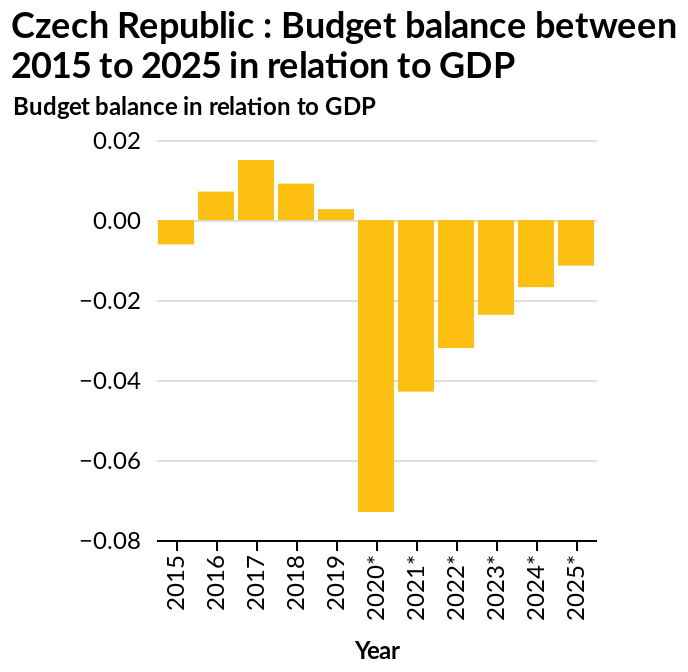<image>
What country does the bar graph represent? The bar graph represents the Czech Republic. What is the value of the bar when it plummets back down in 2020? The value of the bar plummets back down to -0.07 in 2020. What does the x-axis show on the bar graph? The x-axis shows the Year. How would you describe the overall trend of the bar based on the figure? The overall trend of the bar starts in the negatives, peaks above zero, and then plummets back down in 2020. How does the bar change after reaching its peak? The bar peaks above the zero line. What does the y-axis plot on the bar graph? The y-axis plots the Budget balance in relation to GDP. please summary the statistics and relations of the chart Seems like the budget balance in relation to GDP tends to fall since 2020 by roughly half each year. What type of graph is used to represent the budget balance in relation to GDP for the Czech Republic? A bar graph is used to represent the budget balance in relation to GDP for the Czech Republic. please enumerates aspects of the construction of the chart Czech Republic : Budget balance between 2015 to 2025 in relation to GDP is a bar graph. The y-axis plots Budget balance in relation to GDP while the x-axis shows Year. When does the chart experience a significant drop in 2020? The chart experiences a significant drop in 2020. 